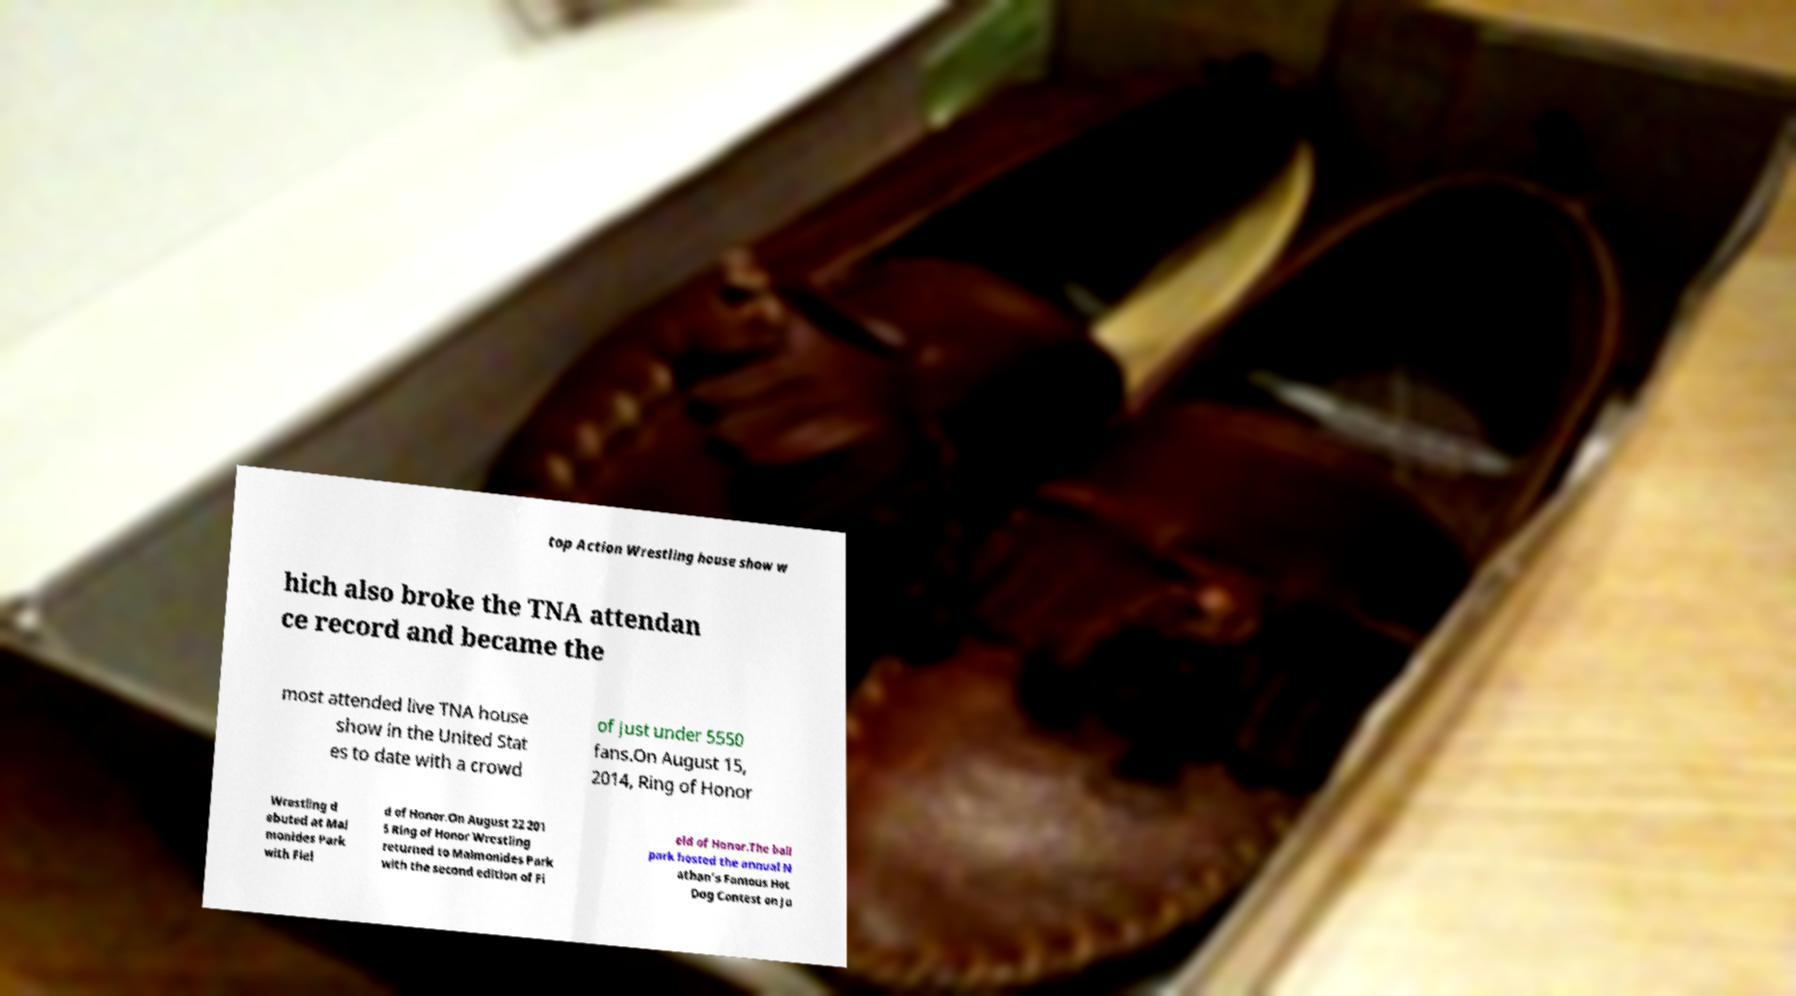What messages or text are displayed in this image? I need them in a readable, typed format. top Action Wrestling house show w hich also broke the TNA attendan ce record and became the most attended live TNA house show in the United Stat es to date with a crowd of just under 5550 fans.On August 15, 2014, Ring of Honor Wrestling d ebuted at Mai monides Park with Fiel d of Honor.On August 22 201 5 Ring of Honor Wrestling returned to Maimonides Park with the second edition of Fi eld of Honor.The ball park hosted the annual N athan's Famous Hot Dog Contest on Ju 